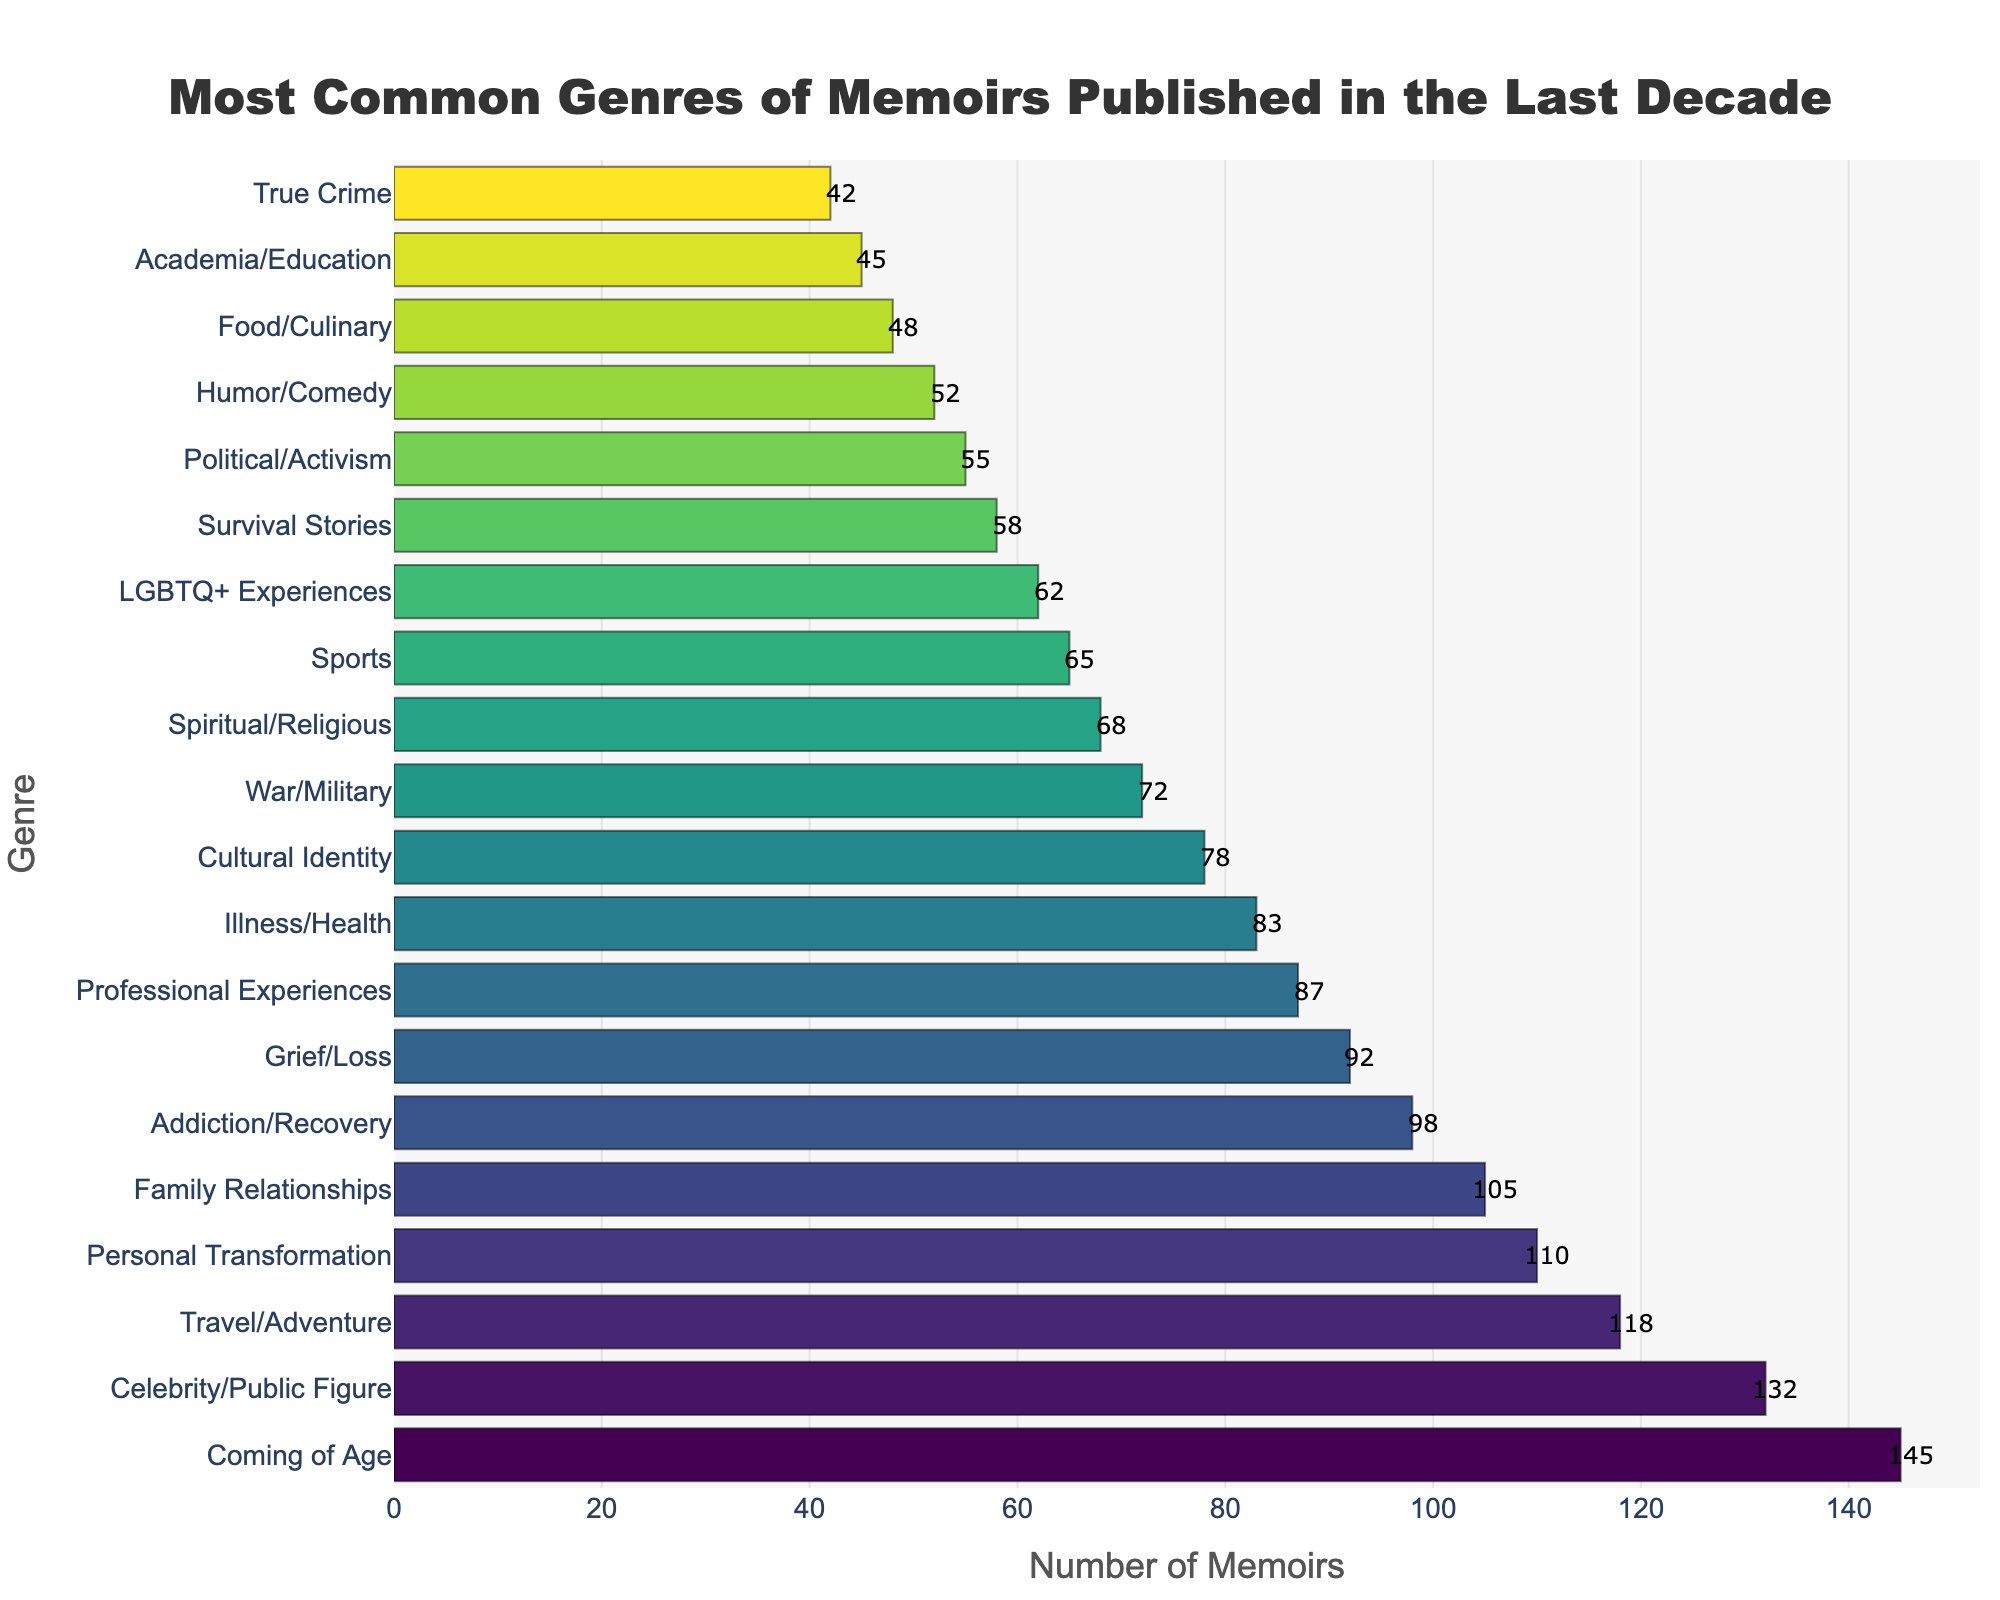What's the most common genre of memoirs published in the last decade? The figure shows the bar representing "Coming of Age" at the very top with the highest value. This indicates it is the most common genre.
Answer: Coming of Age How many more memoirs are there in the "Coming of Age" genre compared to the "True Crime" genre? The "Coming of Age" genre has 145 memoirs, whereas the "True Crime" genre has 42 memoirs. Subtracting these values gives 145 - 42 = 103.
Answer: 103 Which genre has fewer memoirs: "Family Relationships" or "Personal Transformation"? Looking at the lengths of the bars, the "Family Relationships" genre has 105 memoirs, and the "Personal Transformation" genre has 110 memoirs.
Answer: Family Relationships What is the sum of the memoirs in the "Professional Experiences" and "Cultural Identity" genres? From the figure, "Professional Experiences" has 87 memoirs, and "Cultural Identity" has 78 memoirs. Adding these values gives 87 + 78 = 165.
Answer: 165 What is the average number of memoirs in the "Humor/Comedy" and "Food/Culinary" genres? The "Humor/Comedy" genre has 52 memoirs, and the "Food/Culinary" genre has 48 memoirs. Adding these values and dividing by 2 gives (52 + 48) / 2 = 50.
Answer: 50 Between "Travel/Adventure" and "Addiction/Recovery" genres, which one has a greater number of published memoirs and by how much? "Travel/Adventure" has 118 memoirs, and "Addiction/Recovery" has 98 memoirs. The difference is 118 - 98 = 20.
Answer: Travel/Adventure by 20 Which genre has the closest number of memoirs to the average value of all genres? First, find the mean by summing up all values (145 + 132 + 118 + 110 + 105 + 98 + 92 + 87 + 83 + 78 + 72 + 68 + 65 + 62 + 58 + 55 + 52 + 48 + 45 + 42 = 1645) and then dividing by the number of genres (20). The average is 1645 / 20 = 82.25. The "Illness/Health" genre with 83 memoirs is closest to this value.
Answer: Illness/Health What are the third and fourth most common genres of memoirs? Observing the descending order, the third most common is "Travel/Adventure" with 118 memoirs, and the fourth is "Personal Transformation" with 110 memoirs.
Answer: Travel/Adventure, Personal Transformation Which genre has more memoirs: "LGBTQ+ Experiences" or "Spiritual/Religious"? The "Spiritual/Religious" genre has 68 memoirs, while "LGBTQ+ Experiences" has 62 memoirs.
Answer: Spiritual/Religious What is the combined number of memoirs for the least five common genres? The least common genres are "Food/Culinary" (48), "Academia/Education" (45), and "True Crime" (42). Adding these values gives 48 + 45 + 42 = 135.
Answer: 135 